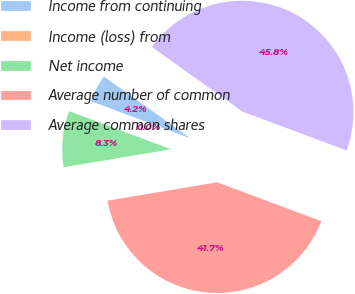Convert chart. <chart><loc_0><loc_0><loc_500><loc_500><pie_chart><fcel>Income from continuing<fcel>Income (loss) from<fcel>Net income<fcel>Average number of common<fcel>Average common shares<nl><fcel>4.17%<fcel>0.0%<fcel>8.33%<fcel>41.67%<fcel>45.83%<nl></chart> 